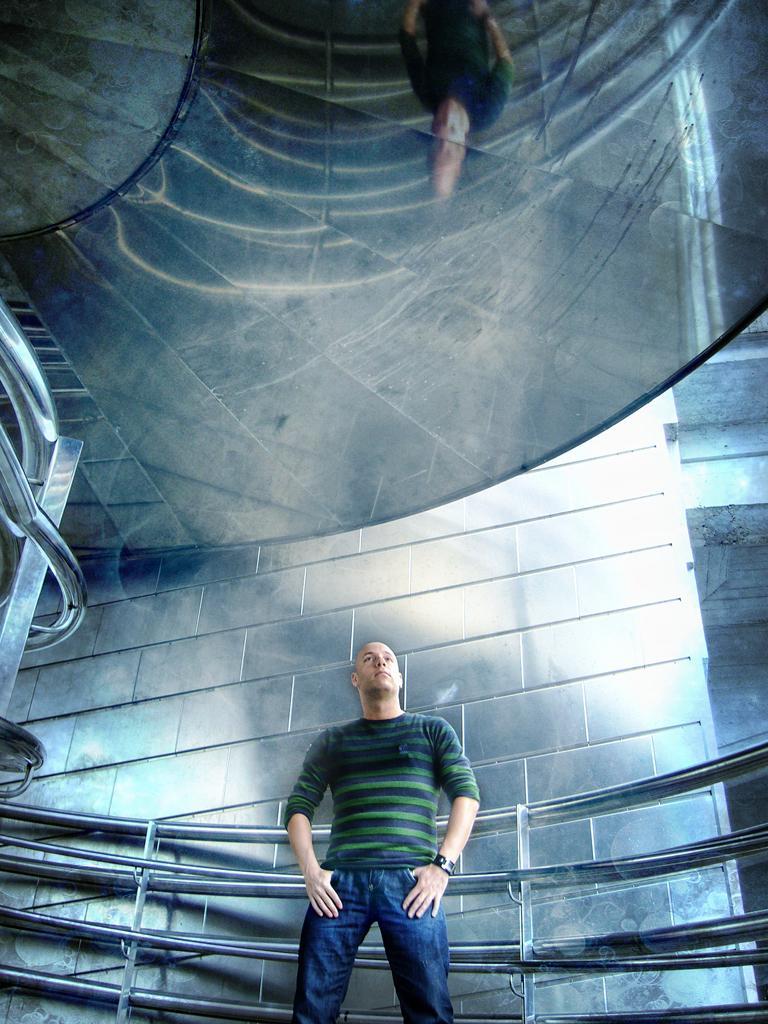Please provide a concise description of this image. In this image we can able to see a person is standing, and he is wearing green color t-shirt and blue color pant, and behind him there is a wall, and we can able to see grills. 